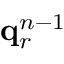Convert formula to latex. <formula><loc_0><loc_0><loc_500><loc_500>q _ { r } ^ { n - 1 }</formula> 